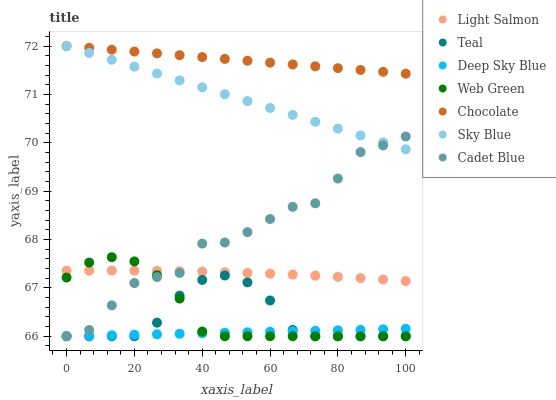Does Deep Sky Blue have the minimum area under the curve?
Answer yes or no. Yes. Does Chocolate have the maximum area under the curve?
Answer yes or no. Yes. Does Cadet Blue have the minimum area under the curve?
Answer yes or no. No. Does Cadet Blue have the maximum area under the curve?
Answer yes or no. No. Is Deep Sky Blue the smoothest?
Answer yes or no. Yes. Is Cadet Blue the roughest?
Answer yes or no. Yes. Is Teal the smoothest?
Answer yes or no. No. Is Teal the roughest?
Answer yes or no. No. Does Cadet Blue have the lowest value?
Answer yes or no. Yes. Does Chocolate have the lowest value?
Answer yes or no. No. Does Sky Blue have the highest value?
Answer yes or no. Yes. Does Cadet Blue have the highest value?
Answer yes or no. No. Is Teal less than Chocolate?
Answer yes or no. Yes. Is Sky Blue greater than Teal?
Answer yes or no. Yes. Does Teal intersect Cadet Blue?
Answer yes or no. Yes. Is Teal less than Cadet Blue?
Answer yes or no. No. Is Teal greater than Cadet Blue?
Answer yes or no. No. Does Teal intersect Chocolate?
Answer yes or no. No. 